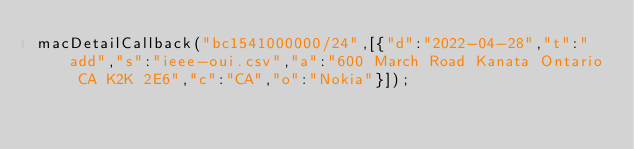<code> <loc_0><loc_0><loc_500><loc_500><_JavaScript_>macDetailCallback("bc1541000000/24",[{"d":"2022-04-28","t":"add","s":"ieee-oui.csv","a":"600 March Road Kanata Ontario CA K2K 2E6","c":"CA","o":"Nokia"}]);
</code> 